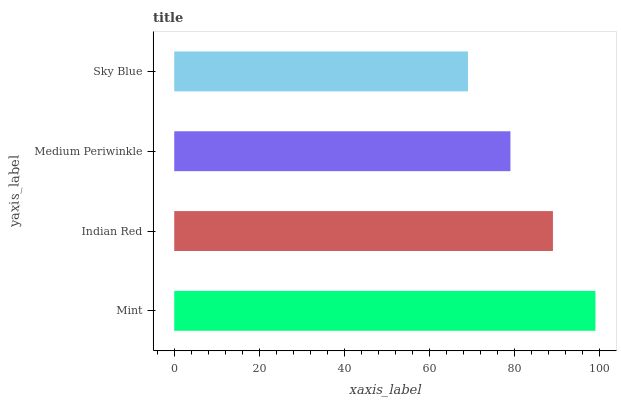Is Sky Blue the minimum?
Answer yes or no. Yes. Is Mint the maximum?
Answer yes or no. Yes. Is Indian Red the minimum?
Answer yes or no. No. Is Indian Red the maximum?
Answer yes or no. No. Is Mint greater than Indian Red?
Answer yes or no. Yes. Is Indian Red less than Mint?
Answer yes or no. Yes. Is Indian Red greater than Mint?
Answer yes or no. No. Is Mint less than Indian Red?
Answer yes or no. No. Is Indian Red the high median?
Answer yes or no. Yes. Is Medium Periwinkle the low median?
Answer yes or no. Yes. Is Medium Periwinkle the high median?
Answer yes or no. No. Is Sky Blue the low median?
Answer yes or no. No. 